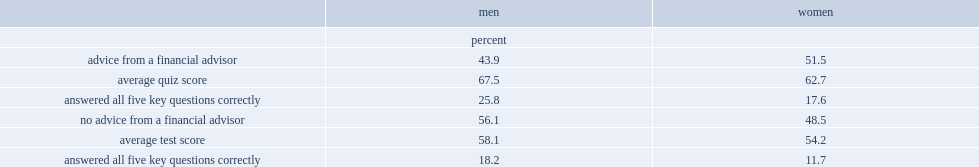Could you parse the entire table as a dict? {'header': ['', 'men', 'women'], 'rows': [['', 'percent', ''], ['advice from a financial advisor', '43.9', '51.5'], ['average quiz score', '67.5', '62.7'], ['answered all five key questions correctly', '25.8', '17.6'], ['no advice from a financial advisor', '56.1', '48.5'], ['average test score', '58.1', '54.2'], ['answered all five key questions correctly', '18.2', '11.7']]} Among men who relied on advice from a financial advisor and who did not rely on advice from a financial advisor,which were more likely to answer the five questions correctly? Advice from a financial advisor. Among women who relied on advice from a financial advisor and who did not rely on advice from a financial advisor,which were more likely to answer the five questions correctly? Advice from a financial advisor. 